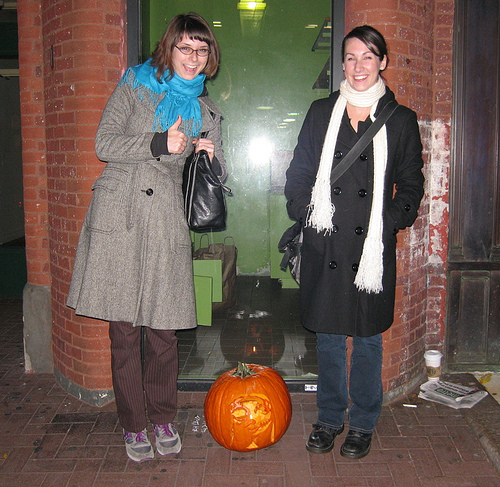<image>
Is the women to the left of the women? Yes. From this viewpoint, the women is positioned to the left side relative to the women. 